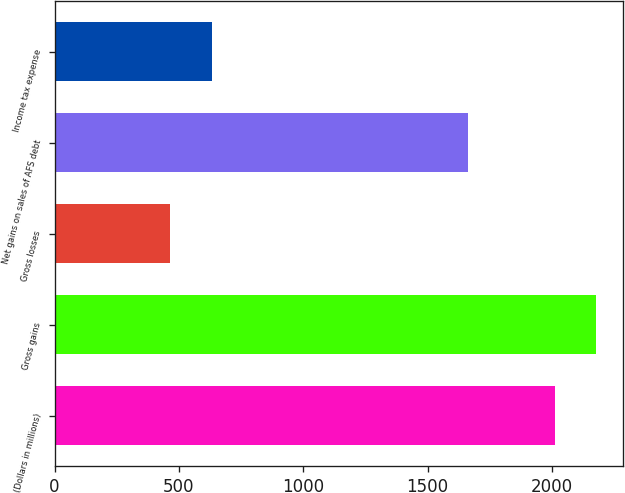<chart> <loc_0><loc_0><loc_500><loc_500><bar_chart><fcel>(Dollars in millions)<fcel>Gross gains<fcel>Gross losses<fcel>Net gains on sales of AFS debt<fcel>Income tax expense<nl><fcel>2012<fcel>2178.2<fcel>466<fcel>1662<fcel>632.2<nl></chart> 